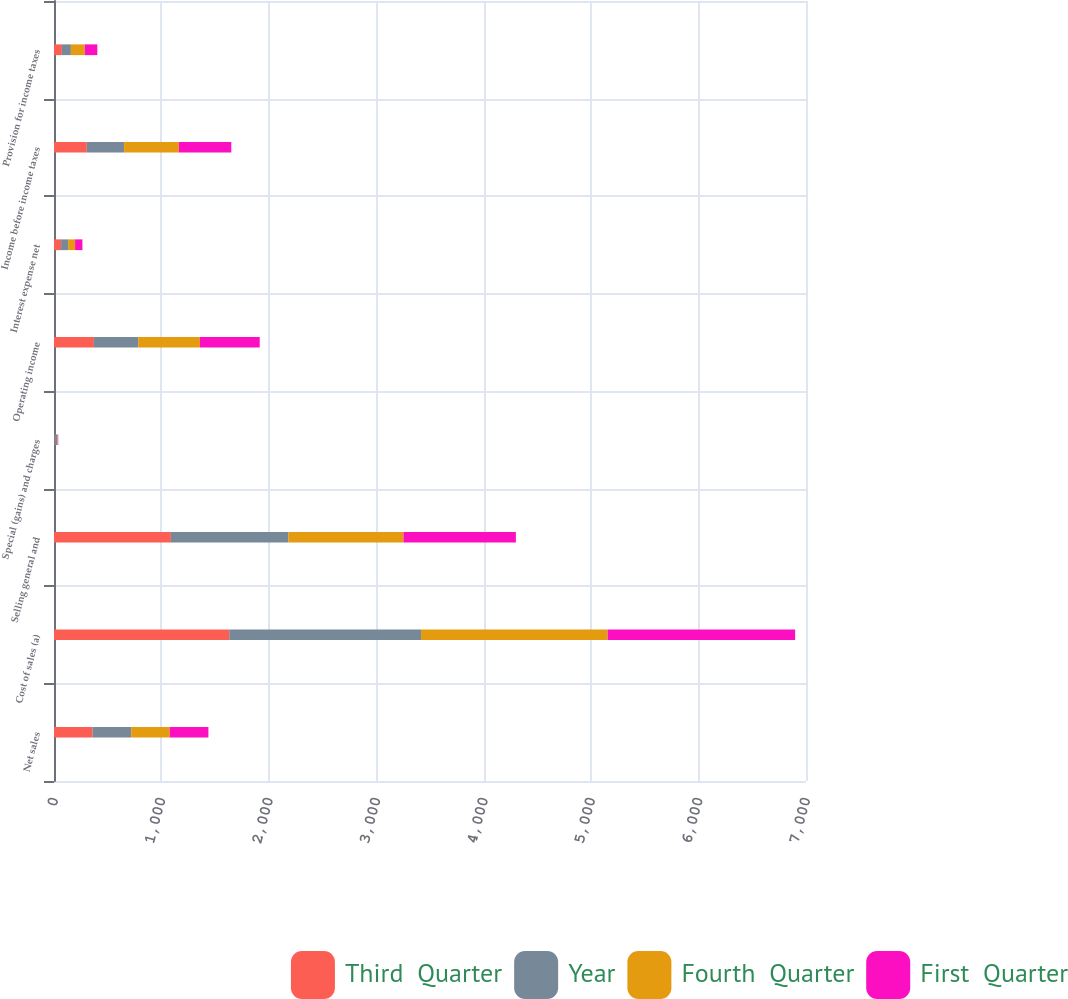Convert chart. <chart><loc_0><loc_0><loc_500><loc_500><stacked_bar_chart><ecel><fcel>Net sales<fcel>Cost of sales (a)<fcel>Selling general and<fcel>Special (gains) and charges<fcel>Operating income<fcel>Interest expense net<fcel>Income before income taxes<fcel>Provision for income taxes<nl><fcel>Third  Quarter<fcel>359.35<fcel>1631.4<fcel>1088.2<fcel>6.3<fcel>371.5<fcel>66.1<fcel>305.4<fcel>73.4<nl><fcel>Year<fcel>359.35<fcel>1785.2<fcel>1093.3<fcel>26.2<fcel>412.5<fcel>65.3<fcel>347.2<fcel>83.6<nl><fcel>Fourth  Quarter<fcel>359.35<fcel>1737.2<fcel>1071.6<fcel>3.2<fcel>574.1<fcel>64.9<fcel>509.2<fcel>129.7<nl><fcel>First  Quarter<fcel>359.35<fcel>1745.1<fcel>1046.3<fcel>3.8<fcel>556.9<fcel>68.3<fcel>488.6<fcel>116.6<nl></chart> 